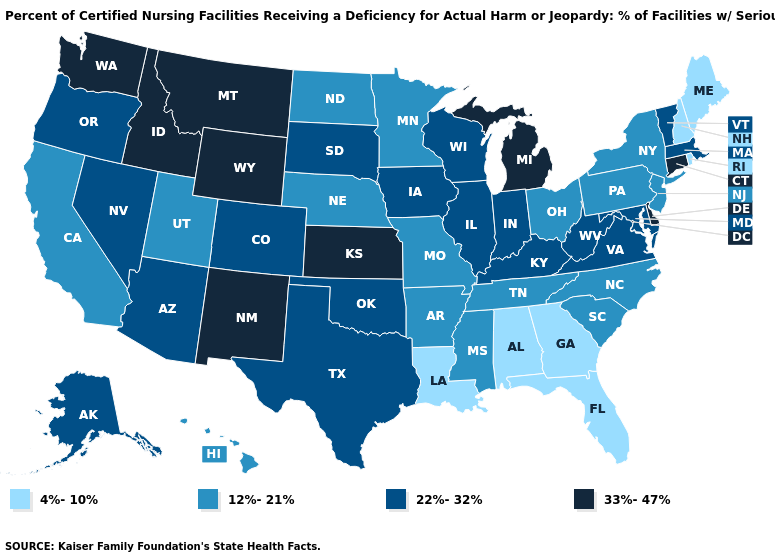What is the value of South Carolina?
Concise answer only. 12%-21%. What is the value of South Dakota?
Short answer required. 22%-32%. Which states hav the highest value in the South?
Quick response, please. Delaware. Name the states that have a value in the range 12%-21%?
Keep it brief. Arkansas, California, Hawaii, Minnesota, Mississippi, Missouri, Nebraska, New Jersey, New York, North Carolina, North Dakota, Ohio, Pennsylvania, South Carolina, Tennessee, Utah. What is the value of Kentucky?
Quick response, please. 22%-32%. What is the value of Nevada?
Answer briefly. 22%-32%. Does Connecticut have the highest value in the USA?
Answer briefly. Yes. What is the value of South Carolina?
Quick response, please. 12%-21%. Name the states that have a value in the range 33%-47%?
Quick response, please. Connecticut, Delaware, Idaho, Kansas, Michigan, Montana, New Mexico, Washington, Wyoming. What is the highest value in the USA?
Short answer required. 33%-47%. Name the states that have a value in the range 33%-47%?
Keep it brief. Connecticut, Delaware, Idaho, Kansas, Michigan, Montana, New Mexico, Washington, Wyoming. Among the states that border Vermont , does New Hampshire have the highest value?
Short answer required. No. What is the value of Connecticut?
Short answer required. 33%-47%. Name the states that have a value in the range 4%-10%?
Concise answer only. Alabama, Florida, Georgia, Louisiana, Maine, New Hampshire, Rhode Island. Does the map have missing data?
Keep it brief. No. 